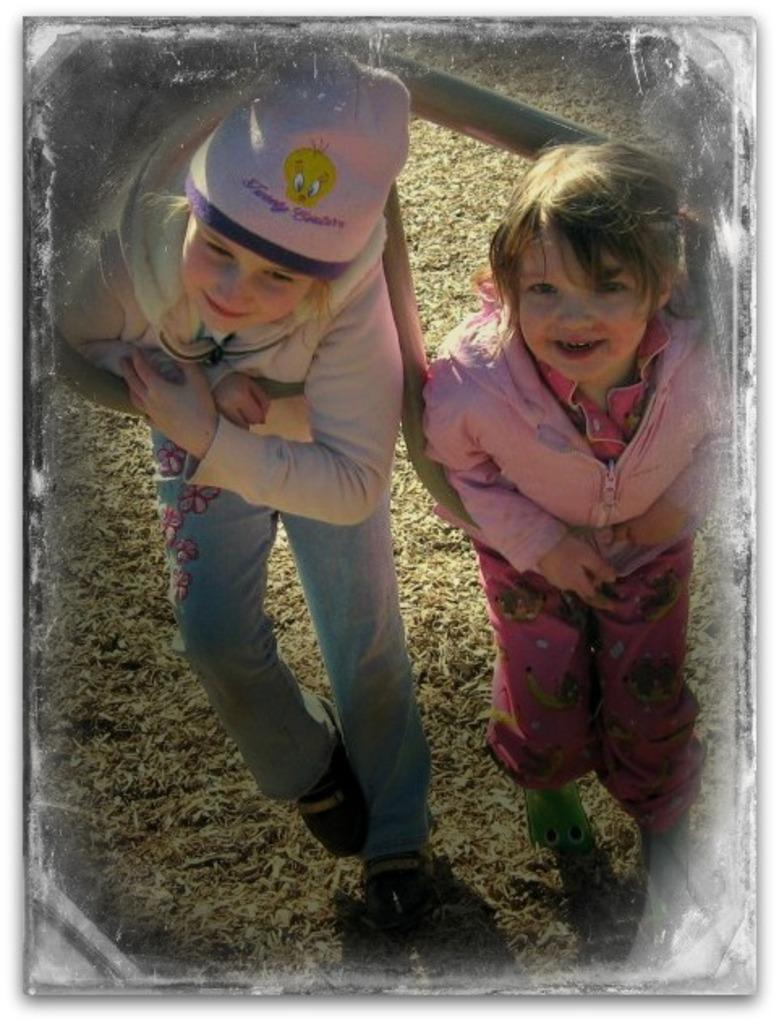How many kids are in the image? There are two kids in the image. What are the kids doing in the image? The kids are laying on poles by holding them. What is visible beneath the kids? There is ground visible in the image, and there is grass on the ground. What can be seen on the head of the girl on the left side? The girl on the left side is wearing a cap. What type of note is the girl on the left side holding in the image? There is no note present in the image; the girl on the left side is wearing a cap. What is being served for dinner in the image? There is no dinner or food visible in the image; it features two kids laying on poles by holding them. 